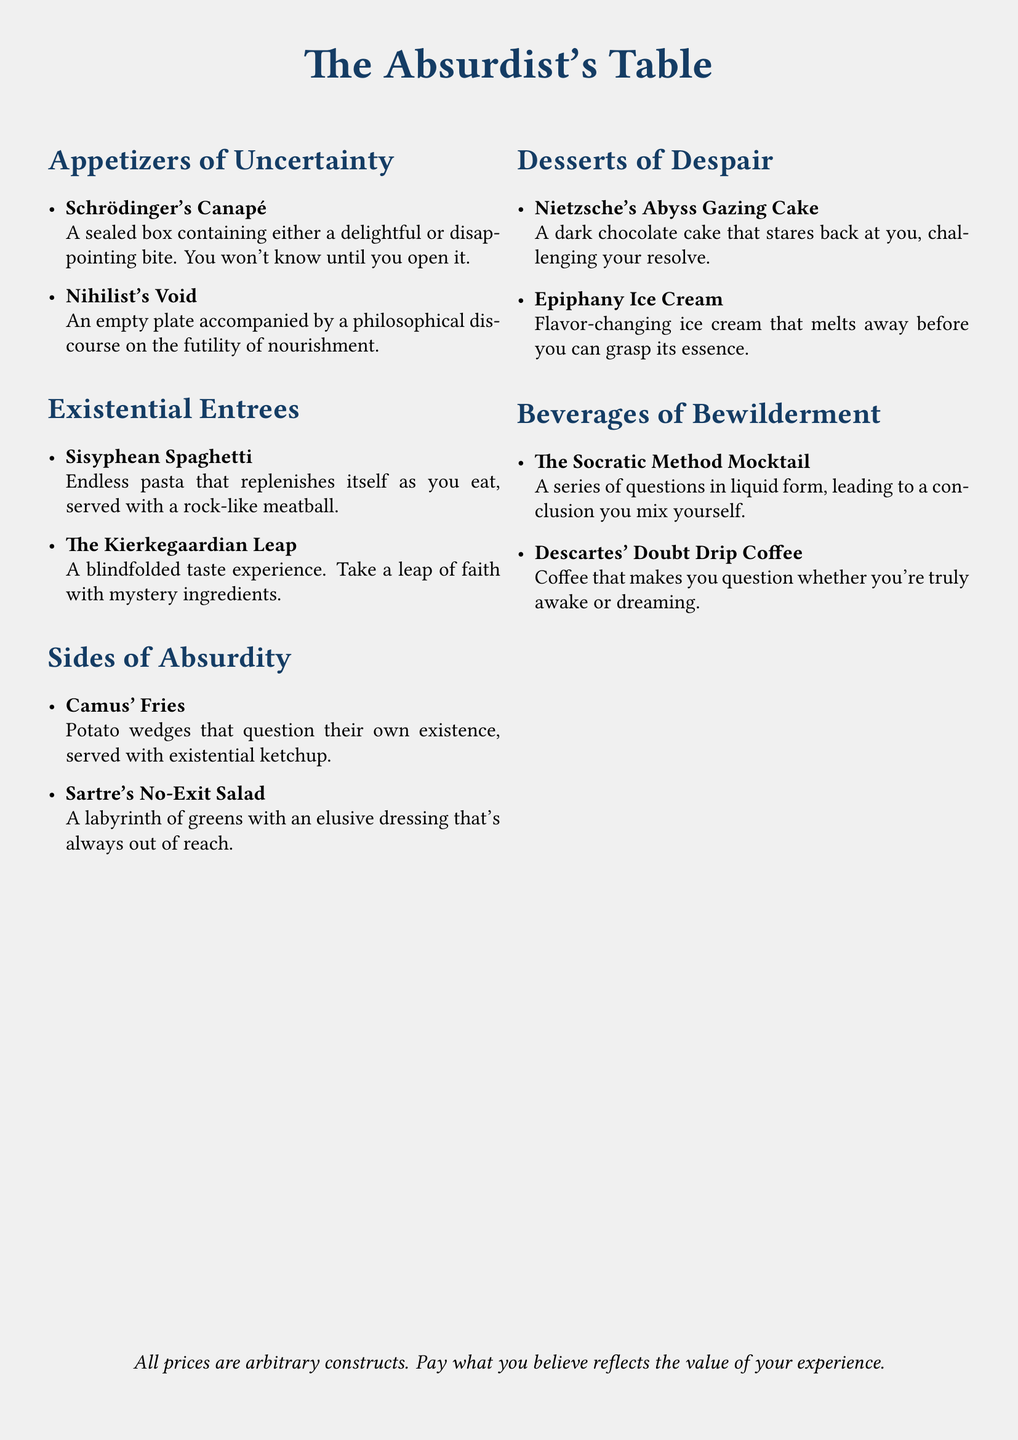what is the name of the restaurant menu? The title of the menu is presented at the top of the document, which is "The Absurdist's Table."
Answer: The Absurdist's Table how many sections are in the menu? The document contains several distinct sections including appetizers, entrees, sides, desserts, and beverages.
Answer: 5 what dish features a blindfolded taste experience? The menu lists an entree that offers this experience, which is "The Kierkegaardian Leap."
Answer: The Kierkegaardian Leap which appetizer is described as an empty plate? The menu indicates that there is an appetizer named "Nihilist's Void," which is an empty plate.
Answer: Nihilist's Void what is unique about Nietzsche's Abyss Gazing Cake? The dessert is described as challenging the diner with its dark chocolate that "stares back at you."
Answer: Stares back at you how is the pricing structured for the dishes? The document states that all prices are arbitrary constructs, reflecting personal belief in value.
Answer: Pay what you believe reflects the value of your experience 